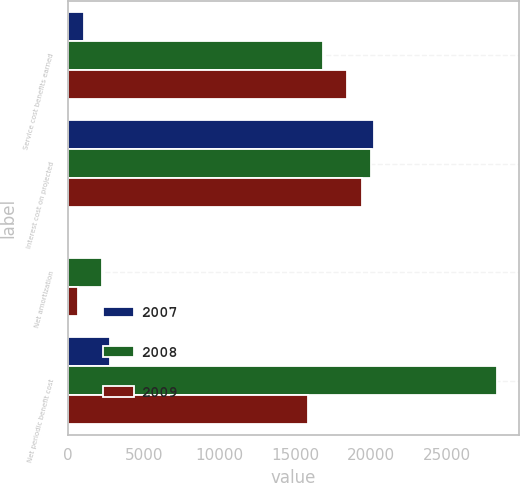<chart> <loc_0><loc_0><loc_500><loc_500><stacked_bar_chart><ecel><fcel>Service cost benefits earned<fcel>Interest cost on projected<fcel>Net amortization<fcel>Net periodic benefit cost<nl><fcel>2007<fcel>1022<fcel>20189<fcel>30<fcel>2802<nl><fcel>2008<fcel>16825<fcel>19991<fcel>2239<fcel>28351<nl><fcel>2009<fcel>18427<fcel>19389<fcel>641<fcel>15852<nl></chart> 